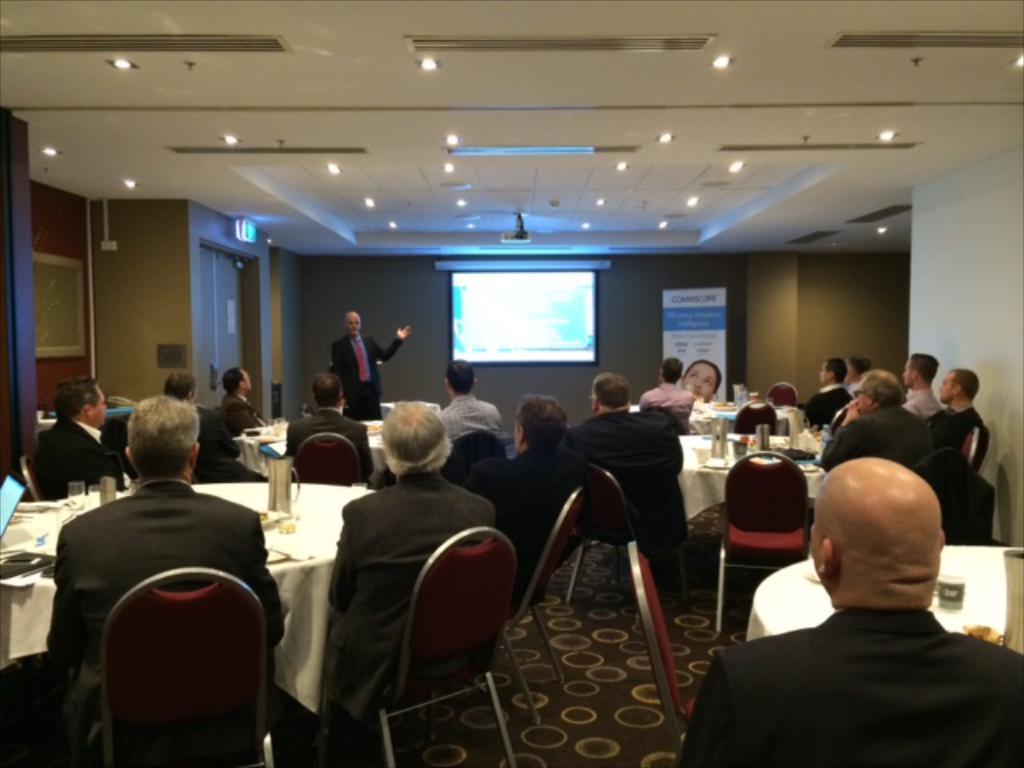How would you summarize this image in a sentence or two? This picture is of inside which is a hall. On the right there is a man seems to be sitting and we can see a table. On the left there are group of persons sitting on the chairs and there are some items placed on the top of the table. In the background we can see a wall, a man standing, a projector screen, a projector and a banner. 